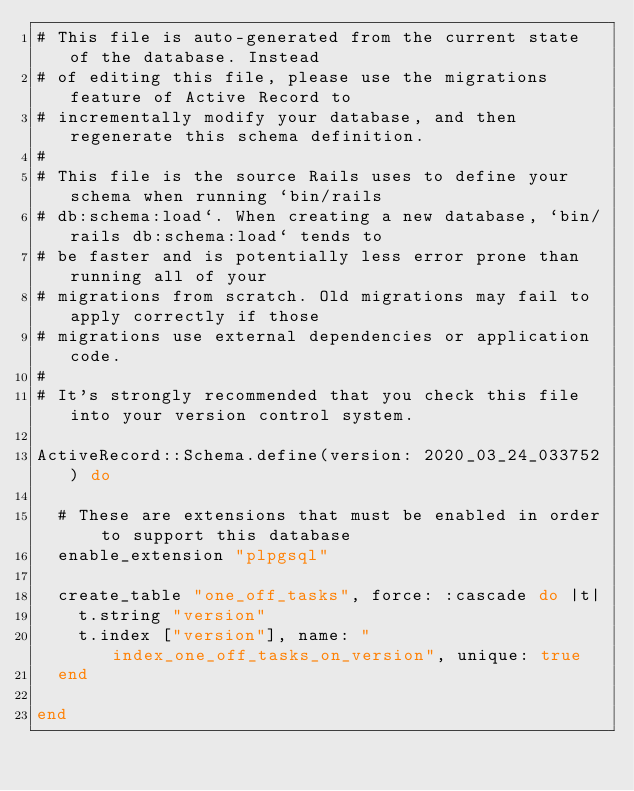Convert code to text. <code><loc_0><loc_0><loc_500><loc_500><_Ruby_># This file is auto-generated from the current state of the database. Instead
# of editing this file, please use the migrations feature of Active Record to
# incrementally modify your database, and then regenerate this schema definition.
#
# This file is the source Rails uses to define your schema when running `bin/rails
# db:schema:load`. When creating a new database, `bin/rails db:schema:load` tends to
# be faster and is potentially less error prone than running all of your
# migrations from scratch. Old migrations may fail to apply correctly if those
# migrations use external dependencies or application code.
#
# It's strongly recommended that you check this file into your version control system.

ActiveRecord::Schema.define(version: 2020_03_24_033752) do

  # These are extensions that must be enabled in order to support this database
  enable_extension "plpgsql"

  create_table "one_off_tasks", force: :cascade do |t|
    t.string "version"
    t.index ["version"], name: "index_one_off_tasks_on_version", unique: true
  end

end
</code> 